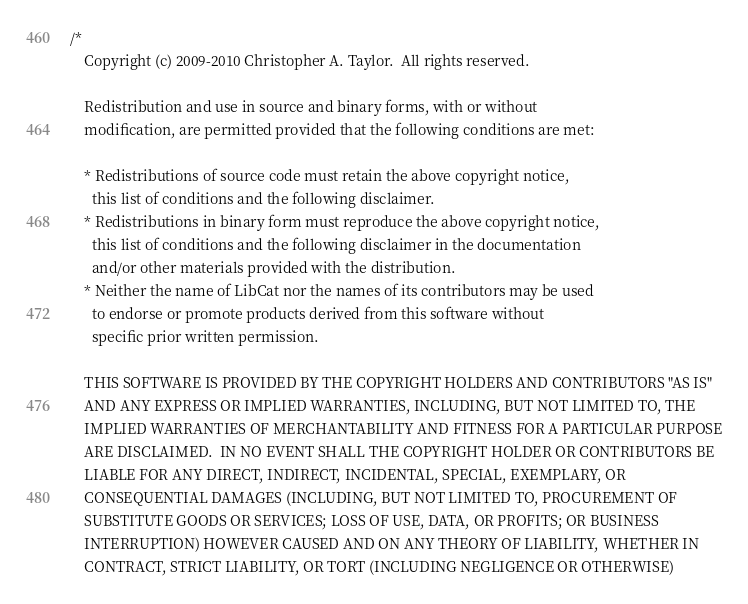<code> <loc_0><loc_0><loc_500><loc_500><_C++_>/*
	Copyright (c) 2009-2010 Christopher A. Taylor.  All rights reserved.

	Redistribution and use in source and binary forms, with or without
	modification, are permitted provided that the following conditions are met:

	* Redistributions of source code must retain the above copyright notice,
	  this list of conditions and the following disclaimer.
	* Redistributions in binary form must reproduce the above copyright notice,
	  this list of conditions and the following disclaimer in the documentation
	  and/or other materials provided with the distribution.
	* Neither the name of LibCat nor the names of its contributors may be used
	  to endorse or promote products derived from this software without
	  specific prior written permission.

	THIS SOFTWARE IS PROVIDED BY THE COPYRIGHT HOLDERS AND CONTRIBUTORS "AS IS"
	AND ANY EXPRESS OR IMPLIED WARRANTIES, INCLUDING, BUT NOT LIMITED TO, THE
	IMPLIED WARRANTIES OF MERCHANTABILITY AND FITNESS FOR A PARTICULAR PURPOSE
	ARE DISCLAIMED.  IN NO EVENT SHALL THE COPYRIGHT HOLDER OR CONTRIBUTORS BE
	LIABLE FOR ANY DIRECT, INDIRECT, INCIDENTAL, SPECIAL, EXEMPLARY, OR
	CONSEQUENTIAL DAMAGES (INCLUDING, BUT NOT LIMITED TO, PROCUREMENT OF
	SUBSTITUTE GOODS OR SERVICES; LOSS OF USE, DATA, OR PROFITS; OR BUSINESS
	INTERRUPTION) HOWEVER CAUSED AND ON ANY THEORY OF LIABILITY, WHETHER IN
	CONTRACT, STRICT LIABILITY, OR TORT (INCLUDING NEGLIGENCE OR OTHERWISE)</code> 